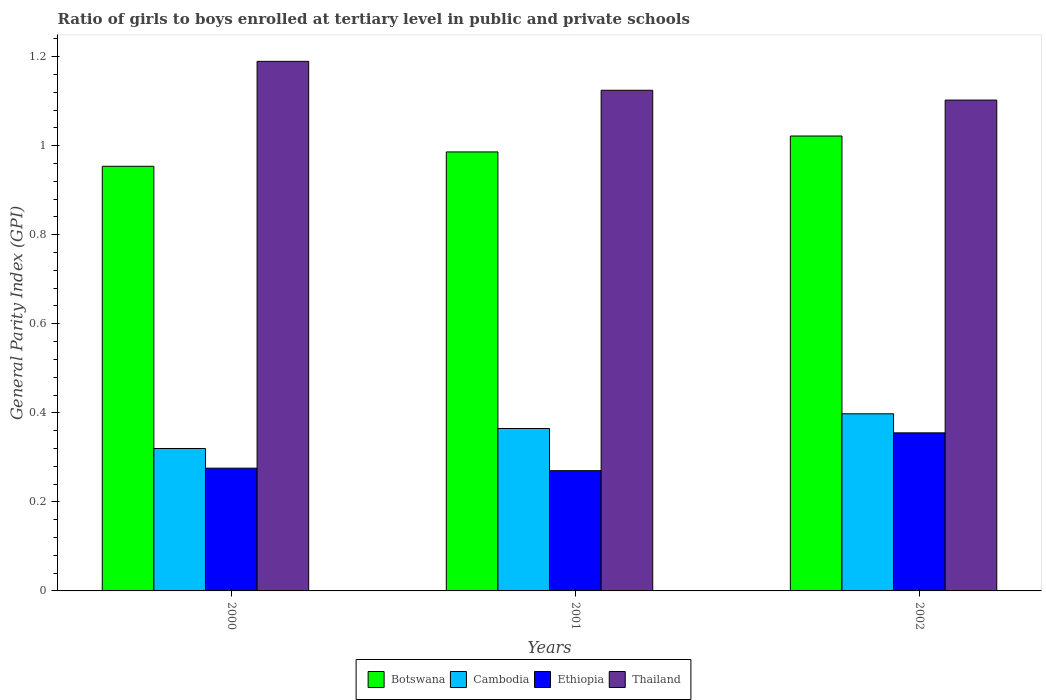How many different coloured bars are there?
Offer a terse response. 4. How many groups of bars are there?
Give a very brief answer. 3. Are the number of bars per tick equal to the number of legend labels?
Give a very brief answer. Yes. How many bars are there on the 3rd tick from the left?
Make the answer very short. 4. In how many cases, is the number of bars for a given year not equal to the number of legend labels?
Your response must be concise. 0. What is the general parity index in Botswana in 2000?
Offer a very short reply. 0.95. Across all years, what is the maximum general parity index in Botswana?
Offer a very short reply. 1.02. Across all years, what is the minimum general parity index in Botswana?
Give a very brief answer. 0.95. What is the total general parity index in Cambodia in the graph?
Make the answer very short. 1.08. What is the difference between the general parity index in Cambodia in 2001 and that in 2002?
Your answer should be very brief. -0.03. What is the difference between the general parity index in Thailand in 2000 and the general parity index in Cambodia in 2002?
Make the answer very short. 0.79. What is the average general parity index in Thailand per year?
Give a very brief answer. 1.14. In the year 2001, what is the difference between the general parity index in Thailand and general parity index in Cambodia?
Keep it short and to the point. 0.76. In how many years, is the general parity index in Thailand greater than 0.04?
Make the answer very short. 3. What is the ratio of the general parity index in Cambodia in 2001 to that in 2002?
Provide a short and direct response. 0.92. What is the difference between the highest and the second highest general parity index in Cambodia?
Make the answer very short. 0.03. What is the difference between the highest and the lowest general parity index in Cambodia?
Your answer should be compact. 0.08. Is the sum of the general parity index in Thailand in 2000 and 2002 greater than the maximum general parity index in Ethiopia across all years?
Your answer should be compact. Yes. What does the 4th bar from the left in 2001 represents?
Provide a short and direct response. Thailand. What does the 2nd bar from the right in 2001 represents?
Give a very brief answer. Ethiopia. How many years are there in the graph?
Offer a very short reply. 3. What is the difference between two consecutive major ticks on the Y-axis?
Offer a terse response. 0.2. Are the values on the major ticks of Y-axis written in scientific E-notation?
Ensure brevity in your answer.  No. Does the graph contain grids?
Give a very brief answer. No. Where does the legend appear in the graph?
Keep it short and to the point. Bottom center. How many legend labels are there?
Offer a very short reply. 4. How are the legend labels stacked?
Make the answer very short. Horizontal. What is the title of the graph?
Give a very brief answer. Ratio of girls to boys enrolled at tertiary level in public and private schools. What is the label or title of the X-axis?
Your response must be concise. Years. What is the label or title of the Y-axis?
Your response must be concise. General Parity Index (GPI). What is the General Parity Index (GPI) of Botswana in 2000?
Your answer should be compact. 0.95. What is the General Parity Index (GPI) of Cambodia in 2000?
Offer a very short reply. 0.32. What is the General Parity Index (GPI) of Ethiopia in 2000?
Your answer should be compact. 0.28. What is the General Parity Index (GPI) of Thailand in 2000?
Make the answer very short. 1.19. What is the General Parity Index (GPI) of Botswana in 2001?
Your answer should be very brief. 0.99. What is the General Parity Index (GPI) of Cambodia in 2001?
Your response must be concise. 0.36. What is the General Parity Index (GPI) of Ethiopia in 2001?
Your answer should be very brief. 0.27. What is the General Parity Index (GPI) of Thailand in 2001?
Your response must be concise. 1.12. What is the General Parity Index (GPI) in Botswana in 2002?
Your answer should be very brief. 1.02. What is the General Parity Index (GPI) of Cambodia in 2002?
Provide a succinct answer. 0.4. What is the General Parity Index (GPI) of Ethiopia in 2002?
Provide a short and direct response. 0.36. What is the General Parity Index (GPI) in Thailand in 2002?
Offer a very short reply. 1.1. Across all years, what is the maximum General Parity Index (GPI) of Botswana?
Your answer should be very brief. 1.02. Across all years, what is the maximum General Parity Index (GPI) of Cambodia?
Your response must be concise. 0.4. Across all years, what is the maximum General Parity Index (GPI) of Ethiopia?
Keep it short and to the point. 0.36. Across all years, what is the maximum General Parity Index (GPI) in Thailand?
Your response must be concise. 1.19. Across all years, what is the minimum General Parity Index (GPI) in Botswana?
Make the answer very short. 0.95. Across all years, what is the minimum General Parity Index (GPI) in Cambodia?
Ensure brevity in your answer.  0.32. Across all years, what is the minimum General Parity Index (GPI) of Ethiopia?
Your response must be concise. 0.27. Across all years, what is the minimum General Parity Index (GPI) in Thailand?
Provide a succinct answer. 1.1. What is the total General Parity Index (GPI) in Botswana in the graph?
Provide a succinct answer. 2.96. What is the total General Parity Index (GPI) in Cambodia in the graph?
Offer a terse response. 1.08. What is the total General Parity Index (GPI) of Ethiopia in the graph?
Keep it short and to the point. 0.9. What is the total General Parity Index (GPI) in Thailand in the graph?
Offer a terse response. 3.42. What is the difference between the General Parity Index (GPI) of Botswana in 2000 and that in 2001?
Ensure brevity in your answer.  -0.03. What is the difference between the General Parity Index (GPI) of Cambodia in 2000 and that in 2001?
Ensure brevity in your answer.  -0.04. What is the difference between the General Parity Index (GPI) of Ethiopia in 2000 and that in 2001?
Your answer should be compact. 0.01. What is the difference between the General Parity Index (GPI) in Thailand in 2000 and that in 2001?
Provide a short and direct response. 0.06. What is the difference between the General Parity Index (GPI) of Botswana in 2000 and that in 2002?
Make the answer very short. -0.07. What is the difference between the General Parity Index (GPI) in Cambodia in 2000 and that in 2002?
Ensure brevity in your answer.  -0.08. What is the difference between the General Parity Index (GPI) of Ethiopia in 2000 and that in 2002?
Your response must be concise. -0.08. What is the difference between the General Parity Index (GPI) in Thailand in 2000 and that in 2002?
Provide a short and direct response. 0.09. What is the difference between the General Parity Index (GPI) in Botswana in 2001 and that in 2002?
Your answer should be very brief. -0.04. What is the difference between the General Parity Index (GPI) of Cambodia in 2001 and that in 2002?
Your answer should be very brief. -0.03. What is the difference between the General Parity Index (GPI) in Ethiopia in 2001 and that in 2002?
Keep it short and to the point. -0.08. What is the difference between the General Parity Index (GPI) in Thailand in 2001 and that in 2002?
Your answer should be very brief. 0.02. What is the difference between the General Parity Index (GPI) of Botswana in 2000 and the General Parity Index (GPI) of Cambodia in 2001?
Offer a terse response. 0.59. What is the difference between the General Parity Index (GPI) of Botswana in 2000 and the General Parity Index (GPI) of Ethiopia in 2001?
Provide a short and direct response. 0.68. What is the difference between the General Parity Index (GPI) in Botswana in 2000 and the General Parity Index (GPI) in Thailand in 2001?
Ensure brevity in your answer.  -0.17. What is the difference between the General Parity Index (GPI) in Cambodia in 2000 and the General Parity Index (GPI) in Ethiopia in 2001?
Provide a succinct answer. 0.05. What is the difference between the General Parity Index (GPI) of Cambodia in 2000 and the General Parity Index (GPI) of Thailand in 2001?
Your answer should be very brief. -0.8. What is the difference between the General Parity Index (GPI) of Ethiopia in 2000 and the General Parity Index (GPI) of Thailand in 2001?
Your answer should be compact. -0.85. What is the difference between the General Parity Index (GPI) of Botswana in 2000 and the General Parity Index (GPI) of Cambodia in 2002?
Make the answer very short. 0.56. What is the difference between the General Parity Index (GPI) of Botswana in 2000 and the General Parity Index (GPI) of Ethiopia in 2002?
Ensure brevity in your answer.  0.6. What is the difference between the General Parity Index (GPI) in Botswana in 2000 and the General Parity Index (GPI) in Thailand in 2002?
Offer a very short reply. -0.15. What is the difference between the General Parity Index (GPI) in Cambodia in 2000 and the General Parity Index (GPI) in Ethiopia in 2002?
Make the answer very short. -0.04. What is the difference between the General Parity Index (GPI) of Cambodia in 2000 and the General Parity Index (GPI) of Thailand in 2002?
Make the answer very short. -0.78. What is the difference between the General Parity Index (GPI) in Ethiopia in 2000 and the General Parity Index (GPI) in Thailand in 2002?
Make the answer very short. -0.83. What is the difference between the General Parity Index (GPI) of Botswana in 2001 and the General Parity Index (GPI) of Cambodia in 2002?
Offer a very short reply. 0.59. What is the difference between the General Parity Index (GPI) in Botswana in 2001 and the General Parity Index (GPI) in Ethiopia in 2002?
Offer a very short reply. 0.63. What is the difference between the General Parity Index (GPI) of Botswana in 2001 and the General Parity Index (GPI) of Thailand in 2002?
Offer a very short reply. -0.12. What is the difference between the General Parity Index (GPI) of Cambodia in 2001 and the General Parity Index (GPI) of Ethiopia in 2002?
Offer a terse response. 0.01. What is the difference between the General Parity Index (GPI) in Cambodia in 2001 and the General Parity Index (GPI) in Thailand in 2002?
Ensure brevity in your answer.  -0.74. What is the difference between the General Parity Index (GPI) of Ethiopia in 2001 and the General Parity Index (GPI) of Thailand in 2002?
Provide a short and direct response. -0.83. What is the average General Parity Index (GPI) in Botswana per year?
Offer a very short reply. 0.99. What is the average General Parity Index (GPI) in Cambodia per year?
Provide a succinct answer. 0.36. What is the average General Parity Index (GPI) of Ethiopia per year?
Your answer should be compact. 0.3. What is the average General Parity Index (GPI) of Thailand per year?
Your answer should be very brief. 1.14. In the year 2000, what is the difference between the General Parity Index (GPI) in Botswana and General Parity Index (GPI) in Cambodia?
Give a very brief answer. 0.63. In the year 2000, what is the difference between the General Parity Index (GPI) in Botswana and General Parity Index (GPI) in Ethiopia?
Your answer should be compact. 0.68. In the year 2000, what is the difference between the General Parity Index (GPI) in Botswana and General Parity Index (GPI) in Thailand?
Make the answer very short. -0.24. In the year 2000, what is the difference between the General Parity Index (GPI) in Cambodia and General Parity Index (GPI) in Ethiopia?
Offer a very short reply. 0.04. In the year 2000, what is the difference between the General Parity Index (GPI) in Cambodia and General Parity Index (GPI) in Thailand?
Offer a terse response. -0.87. In the year 2000, what is the difference between the General Parity Index (GPI) in Ethiopia and General Parity Index (GPI) in Thailand?
Ensure brevity in your answer.  -0.91. In the year 2001, what is the difference between the General Parity Index (GPI) of Botswana and General Parity Index (GPI) of Cambodia?
Your answer should be very brief. 0.62. In the year 2001, what is the difference between the General Parity Index (GPI) in Botswana and General Parity Index (GPI) in Ethiopia?
Offer a terse response. 0.72. In the year 2001, what is the difference between the General Parity Index (GPI) of Botswana and General Parity Index (GPI) of Thailand?
Your answer should be compact. -0.14. In the year 2001, what is the difference between the General Parity Index (GPI) of Cambodia and General Parity Index (GPI) of Ethiopia?
Provide a succinct answer. 0.09. In the year 2001, what is the difference between the General Parity Index (GPI) in Cambodia and General Parity Index (GPI) in Thailand?
Offer a terse response. -0.76. In the year 2001, what is the difference between the General Parity Index (GPI) of Ethiopia and General Parity Index (GPI) of Thailand?
Offer a very short reply. -0.85. In the year 2002, what is the difference between the General Parity Index (GPI) of Botswana and General Parity Index (GPI) of Cambodia?
Provide a succinct answer. 0.62. In the year 2002, what is the difference between the General Parity Index (GPI) in Botswana and General Parity Index (GPI) in Ethiopia?
Your answer should be compact. 0.67. In the year 2002, what is the difference between the General Parity Index (GPI) in Botswana and General Parity Index (GPI) in Thailand?
Provide a short and direct response. -0.08. In the year 2002, what is the difference between the General Parity Index (GPI) of Cambodia and General Parity Index (GPI) of Ethiopia?
Your answer should be compact. 0.04. In the year 2002, what is the difference between the General Parity Index (GPI) in Cambodia and General Parity Index (GPI) in Thailand?
Provide a short and direct response. -0.7. In the year 2002, what is the difference between the General Parity Index (GPI) of Ethiopia and General Parity Index (GPI) of Thailand?
Keep it short and to the point. -0.75. What is the ratio of the General Parity Index (GPI) of Botswana in 2000 to that in 2001?
Give a very brief answer. 0.97. What is the ratio of the General Parity Index (GPI) in Cambodia in 2000 to that in 2001?
Keep it short and to the point. 0.88. What is the ratio of the General Parity Index (GPI) in Ethiopia in 2000 to that in 2001?
Give a very brief answer. 1.02. What is the ratio of the General Parity Index (GPI) of Thailand in 2000 to that in 2001?
Your answer should be very brief. 1.06. What is the ratio of the General Parity Index (GPI) in Botswana in 2000 to that in 2002?
Make the answer very short. 0.93. What is the ratio of the General Parity Index (GPI) of Cambodia in 2000 to that in 2002?
Provide a succinct answer. 0.8. What is the ratio of the General Parity Index (GPI) of Ethiopia in 2000 to that in 2002?
Offer a terse response. 0.78. What is the ratio of the General Parity Index (GPI) in Thailand in 2000 to that in 2002?
Your answer should be very brief. 1.08. What is the ratio of the General Parity Index (GPI) in Cambodia in 2001 to that in 2002?
Ensure brevity in your answer.  0.92. What is the ratio of the General Parity Index (GPI) in Ethiopia in 2001 to that in 2002?
Offer a terse response. 0.76. What is the difference between the highest and the second highest General Parity Index (GPI) in Botswana?
Offer a very short reply. 0.04. What is the difference between the highest and the second highest General Parity Index (GPI) of Cambodia?
Your response must be concise. 0.03. What is the difference between the highest and the second highest General Parity Index (GPI) in Ethiopia?
Make the answer very short. 0.08. What is the difference between the highest and the second highest General Parity Index (GPI) in Thailand?
Your answer should be compact. 0.06. What is the difference between the highest and the lowest General Parity Index (GPI) of Botswana?
Keep it short and to the point. 0.07. What is the difference between the highest and the lowest General Parity Index (GPI) of Cambodia?
Offer a very short reply. 0.08. What is the difference between the highest and the lowest General Parity Index (GPI) in Ethiopia?
Give a very brief answer. 0.08. What is the difference between the highest and the lowest General Parity Index (GPI) of Thailand?
Your response must be concise. 0.09. 